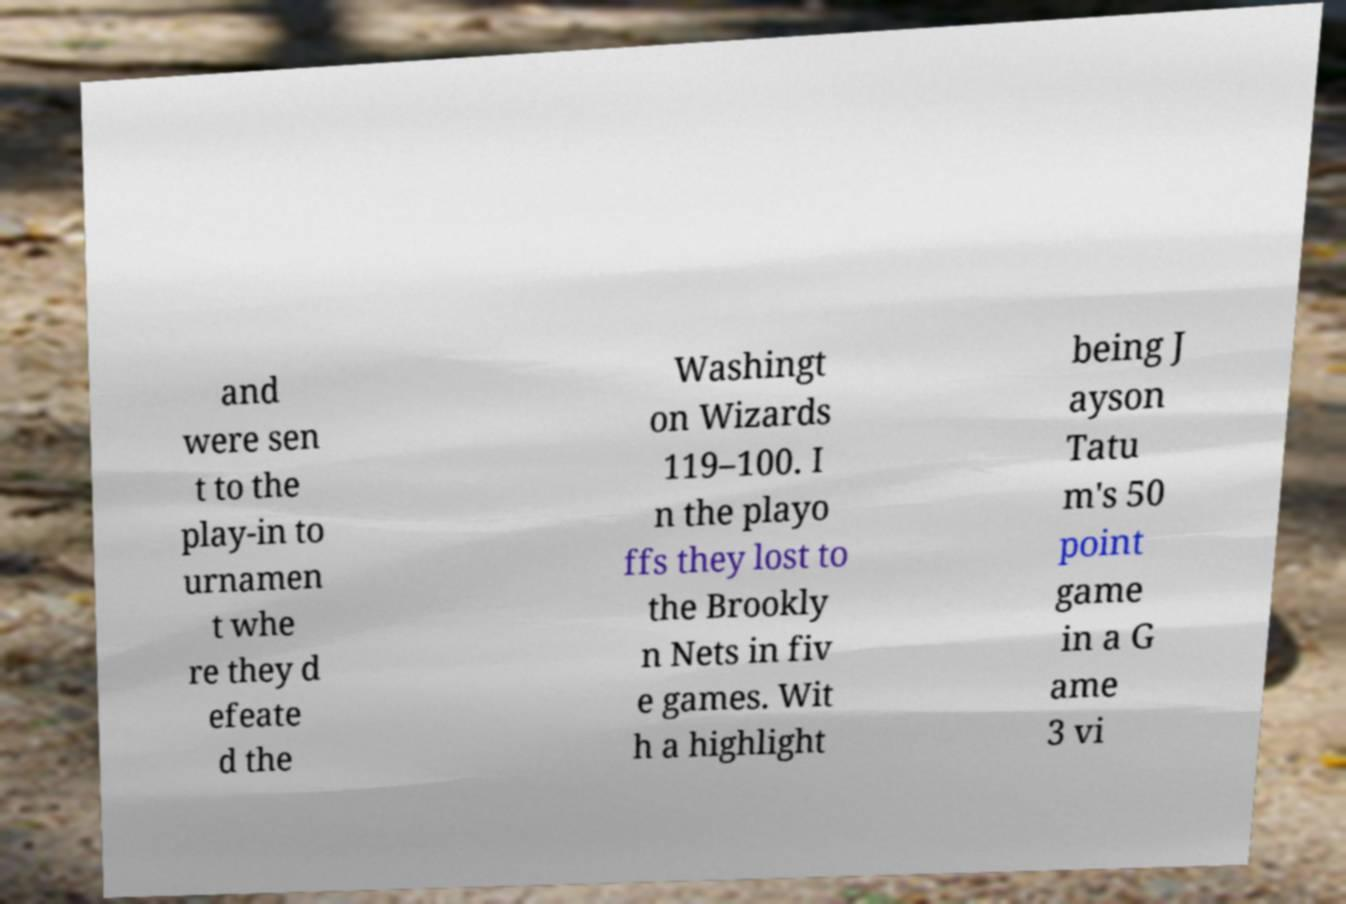What messages or text are displayed in this image? I need them in a readable, typed format. and were sen t to the play-in to urnamen t whe re they d efeate d the Washingt on Wizards 119–100. I n the playo ffs they lost to the Brookly n Nets in fiv e games. Wit h a highlight being J ayson Tatu m's 50 point game in a G ame 3 vi 